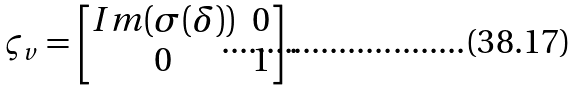Convert formula to latex. <formula><loc_0><loc_0><loc_500><loc_500>\varsigma _ { v } = \begin{bmatrix} I m ( \sigma ( \delta ) ) & 0 \\ 0 & 1 \end{bmatrix} .</formula> 